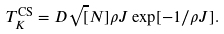Convert formula to latex. <formula><loc_0><loc_0><loc_500><loc_500>T _ { K } ^ { \text {CS} } = D \sqrt { [ } N ] { \rho J } \exp [ - 1 / \rho J ] .</formula> 